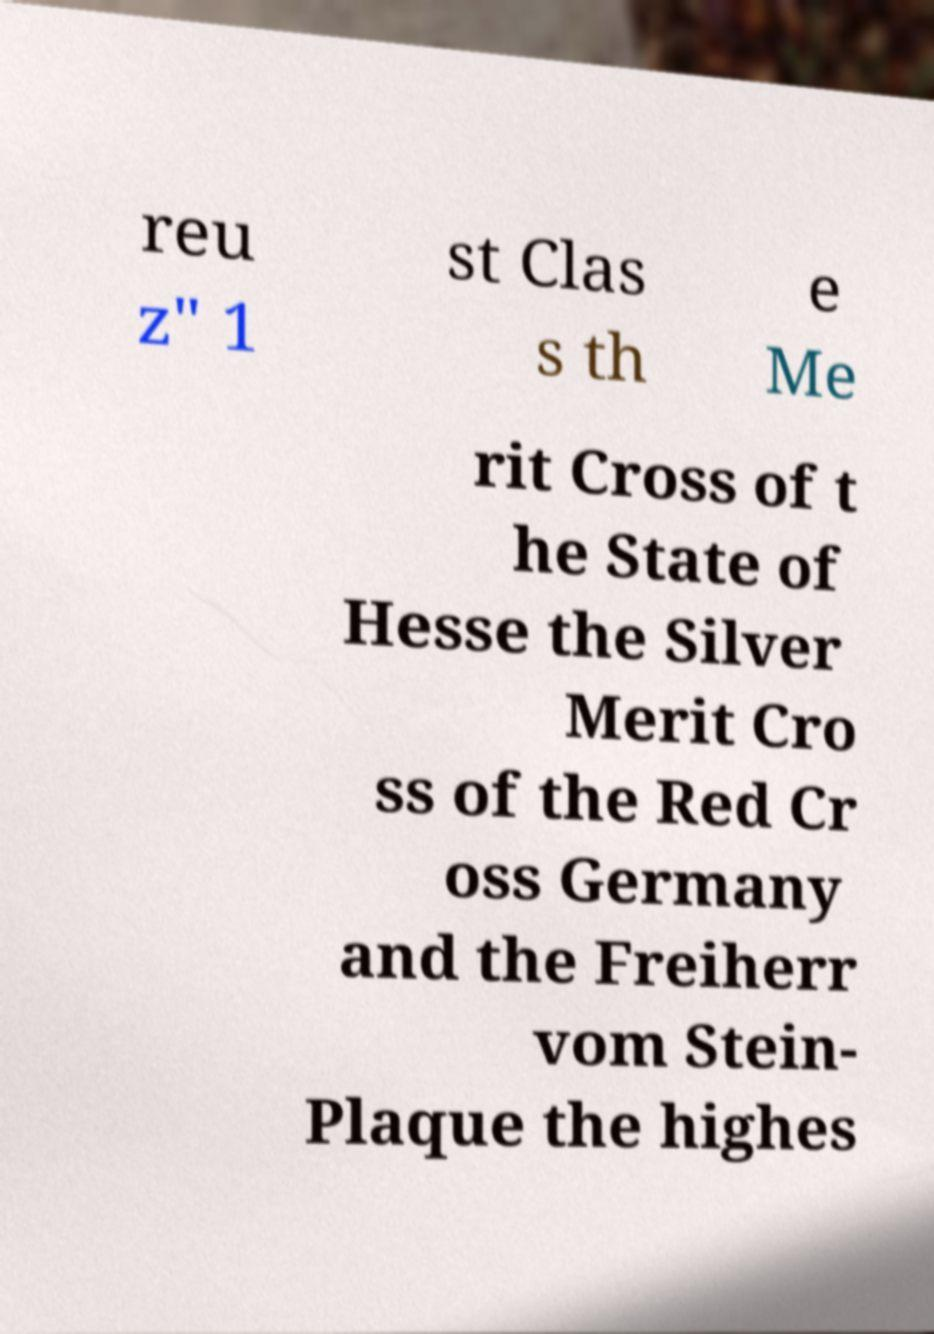Can you read and provide the text displayed in the image?This photo seems to have some interesting text. Can you extract and type it out for me? reu z" 1 st Clas s th e Me rit Cross of t he State of Hesse the Silver Merit Cro ss of the Red Cr oss Germany and the Freiherr vom Stein- Plaque the highes 